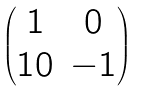Convert formula to latex. <formula><loc_0><loc_0><loc_500><loc_500>\begin{pmatrix} 1 & 0 \\ 1 0 & - 1 \end{pmatrix}</formula> 